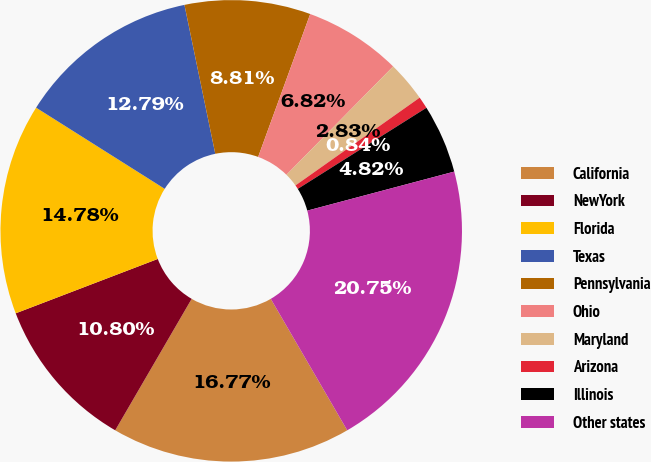Convert chart to OTSL. <chart><loc_0><loc_0><loc_500><loc_500><pie_chart><fcel>California<fcel>NewYork<fcel>Florida<fcel>Texas<fcel>Pennsylvania<fcel>Ohio<fcel>Maryland<fcel>Arizona<fcel>Illinois<fcel>Other states<nl><fcel>16.77%<fcel>10.8%<fcel>14.78%<fcel>12.79%<fcel>8.81%<fcel>6.82%<fcel>2.83%<fcel>0.84%<fcel>4.82%<fcel>20.75%<nl></chart> 